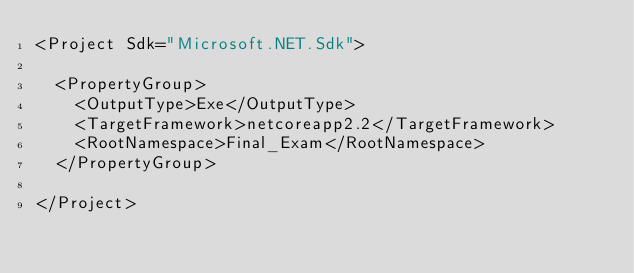<code> <loc_0><loc_0><loc_500><loc_500><_XML_><Project Sdk="Microsoft.NET.Sdk">

  <PropertyGroup>
    <OutputType>Exe</OutputType>
    <TargetFramework>netcoreapp2.2</TargetFramework>
    <RootNamespace>Final_Exam</RootNamespace>
  </PropertyGroup>

</Project>
</code> 